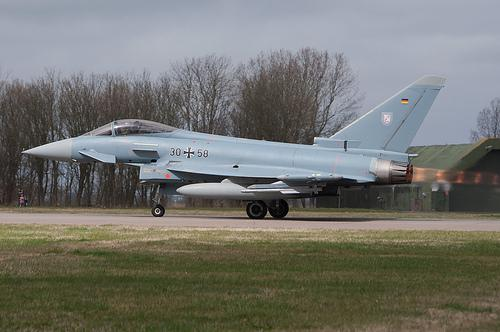Question: why isn't the jet flying?
Choices:
A. It is unloading.
B. It is parked.
C. It is loading.
D. It is being repaired.
Answer with the letter. Answer: B Question: when is this?
Choices:
A. Daytime.
B. Morning.
C. Evening.
D. Sunset.
Answer with the letter. Answer: A Question: who is in the picture?
Choices:
A. A boy.
B. A man and woman.
C. No one is in the picture.
D. A girl.
Answer with the letter. Answer: C Question: how many jets are there?
Choices:
A. Two.
B. Three.
C. One.
D. Four.
Answer with the letter. Answer: C 